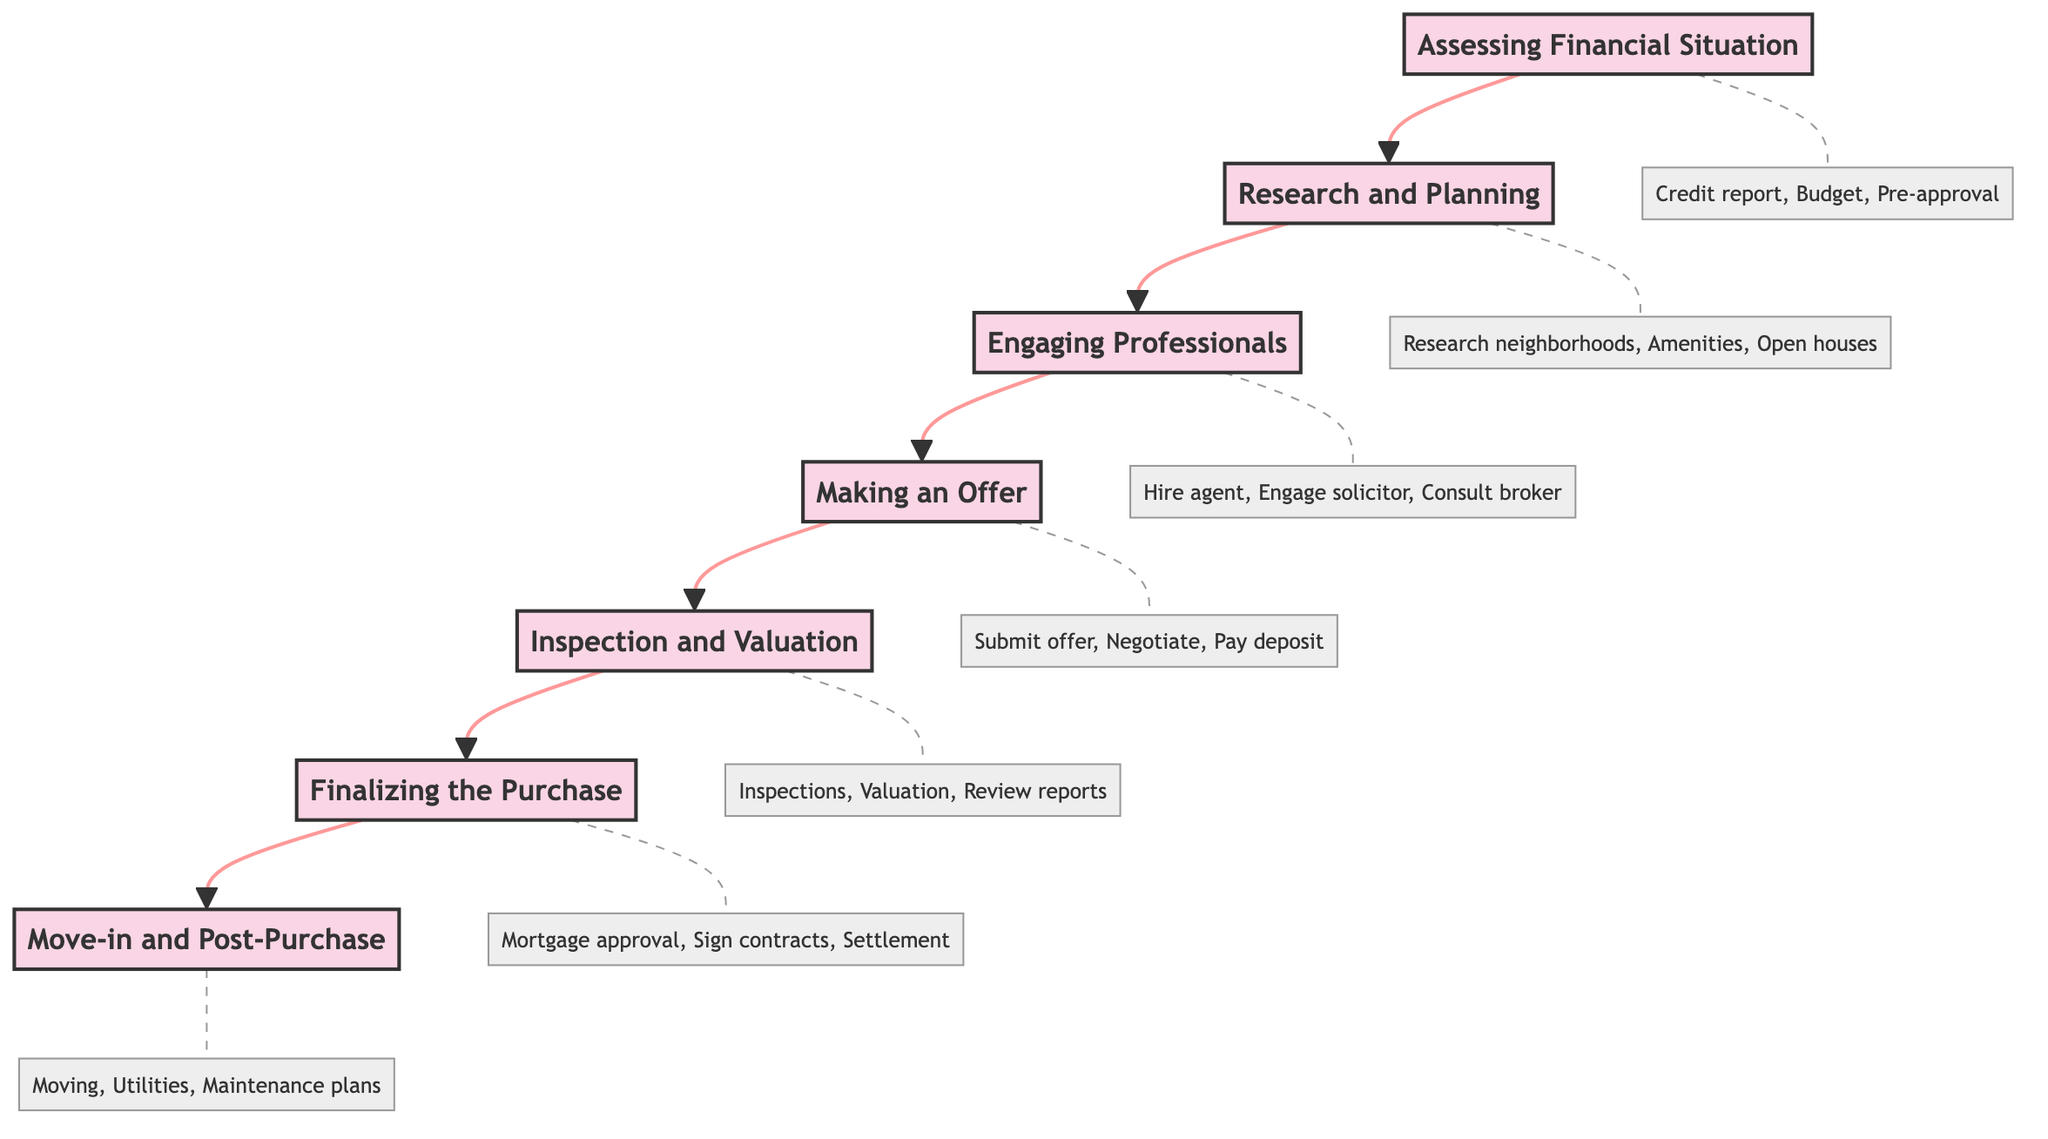What is the first stage of the home buying process? The diagram starts with the node labeled "Assessing Financial Situation," which is positioned at the bottom of the flow chart, indicating it is the first stage.
Answer: Assessing Financial Situation How many stages are there in the home buying process? The diagram shows a total of six distinct stages connected sequentially from the bottom to the top.
Answer: Six Which stage comes after "Making an Offer"? By following the arrows upward from "Making an Offer," the next stage in the sequence is "Inspection and Valuation."
Answer: Inspection and Valuation What tasks are associated with "Research and Planning"? The corresponding details node connected to "Research and Planning" lists three tasks: "Research Auckland neighborhoods," "Identify key amenities and services," and "Attend open houses and inspections."
Answer: Research Auckland neighborhoods, Identify key amenities and services, Attend open houses and inspections What resources are listed under the "Finalizing the Purchase" stage? The details node for "Finalizing the Purchase" specifies three resources: "Lenders," "Conveyancers," and "Settlement agents."
Answer: Lenders, Conveyancers, Settlement agents What stage follows "Engaging Professionals"? The flowchart connects "Engaging Professionals" directly to the next stage labeled "Making an Offer" as part of the sequential progression.
Answer: Making an Offer Which resource is associated with the "Inspection and Valuation" stage? The diagram indicates that "Registered property valuers" is one of the resources listed under the "Inspection and Valuation" stage, highlighting its relevance to that step.
Answer: Registered property valuers List all tasks included in the "Move-in and Post-Purchase" stage. The corresponding details for "Move-in and Post-Purchase" specify three tasks: "Arrange moving services," "Set up utilities and services," and "Review property maintenance plans."
Answer: Arrange moving services, Set up utilities and services, Review property maintenance plans What is the main purpose of the "Assessing Financial Situation" stage? This stage includes crucial tasks like reviewing credit reports, determining budgets and savings, and getting mortgage pre-approval, indicating its focus on establishing financial readiness for buying a home.
Answer: Review credit report and score, Determine budget and savings, Get pre-approval for a mortgage 